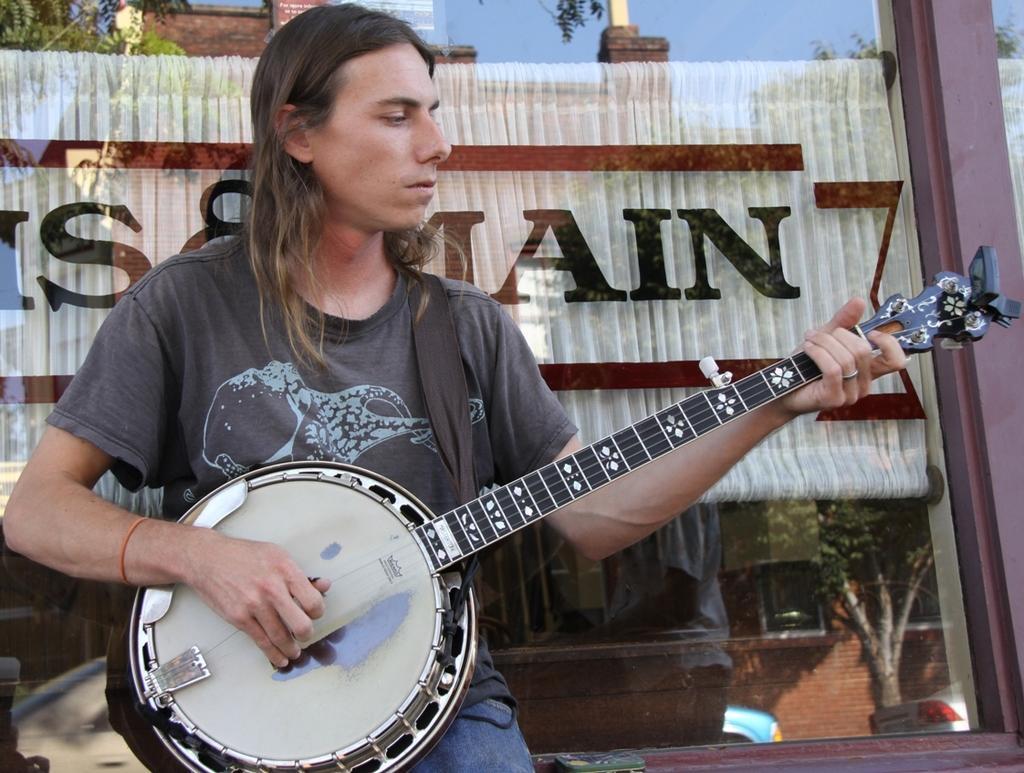In one or two sentences, can you explain what this image depicts? In this image I can see a man wearing t-shirt and sitting on the bench, holding some musical instrument in his hands. In the background I can see a wall. 